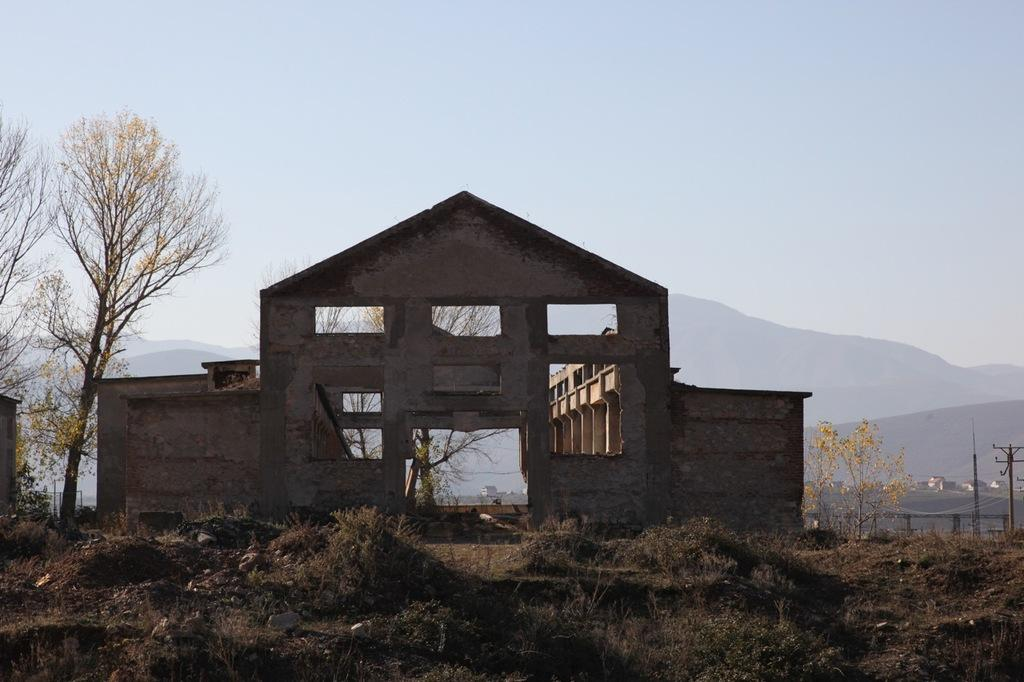What type of structure is present in the image? There is a building in the image. What is the condition of the ground in the image? The ground is covered with dry grass. What type of vegetation can be seen in the image? There are trees visible in the image. What type of basin is used to collect rainwater in the image? There is no basin present in the image to collect rainwater. How are the trees in the image being sorted? The trees in the image are not being sorted; they are simply visible in the image. 